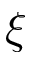<formula> <loc_0><loc_0><loc_500><loc_500>\xi</formula> 